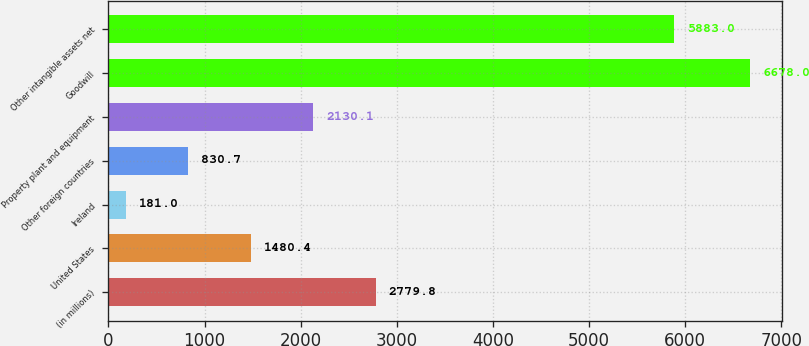Convert chart. <chart><loc_0><loc_0><loc_500><loc_500><bar_chart><fcel>(in millions)<fcel>United States<fcel>Ireland<fcel>Other foreign countries<fcel>Property plant and equipment<fcel>Goodwill<fcel>Other intangible assets net<nl><fcel>2779.8<fcel>1480.4<fcel>181<fcel>830.7<fcel>2130.1<fcel>6678<fcel>5883<nl></chart> 